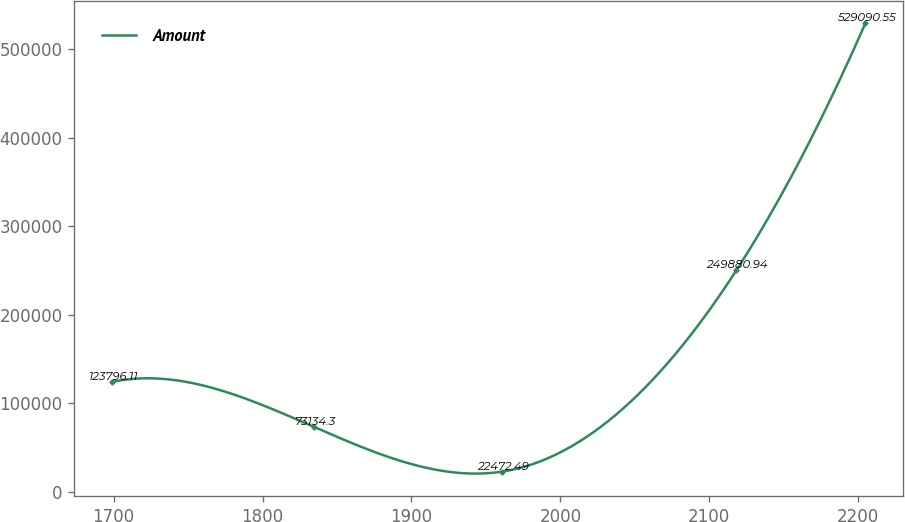Convert chart. <chart><loc_0><loc_0><loc_500><loc_500><line_chart><ecel><fcel>Amount<nl><fcel>1698.77<fcel>123796<nl><fcel>1834.38<fcel>73134.3<nl><fcel>1960.86<fcel>22472.5<nl><fcel>2118.12<fcel>249881<nl><fcel>2204.77<fcel>529091<nl></chart> 